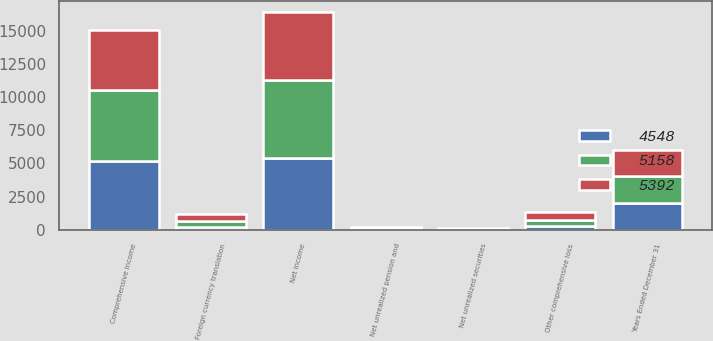Convert chart to OTSL. <chart><loc_0><loc_0><loc_500><loc_500><stacked_bar_chart><ecel><fcel>Years Ended December 31<fcel>Net income<fcel>Net unrealized securities<fcel>Foreign currency translation<fcel>Net unrealized pension and<fcel>Other comprehensive loss<fcel>Comprehensive income<nl><fcel>4548<fcel>2016<fcel>5408<fcel>51<fcel>218<fcel>19<fcel>250<fcel>5158<nl><fcel>5392<fcel>2015<fcel>5163<fcel>38<fcel>545<fcel>32<fcel>615<fcel>4548<nl><fcel>5158<fcel>2014<fcel>5885<fcel>33<fcel>409<fcel>117<fcel>493<fcel>5392<nl></chart> 